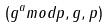Convert formula to latex. <formula><loc_0><loc_0><loc_500><loc_500>( g ^ { a } m o d p , g , p )</formula> 